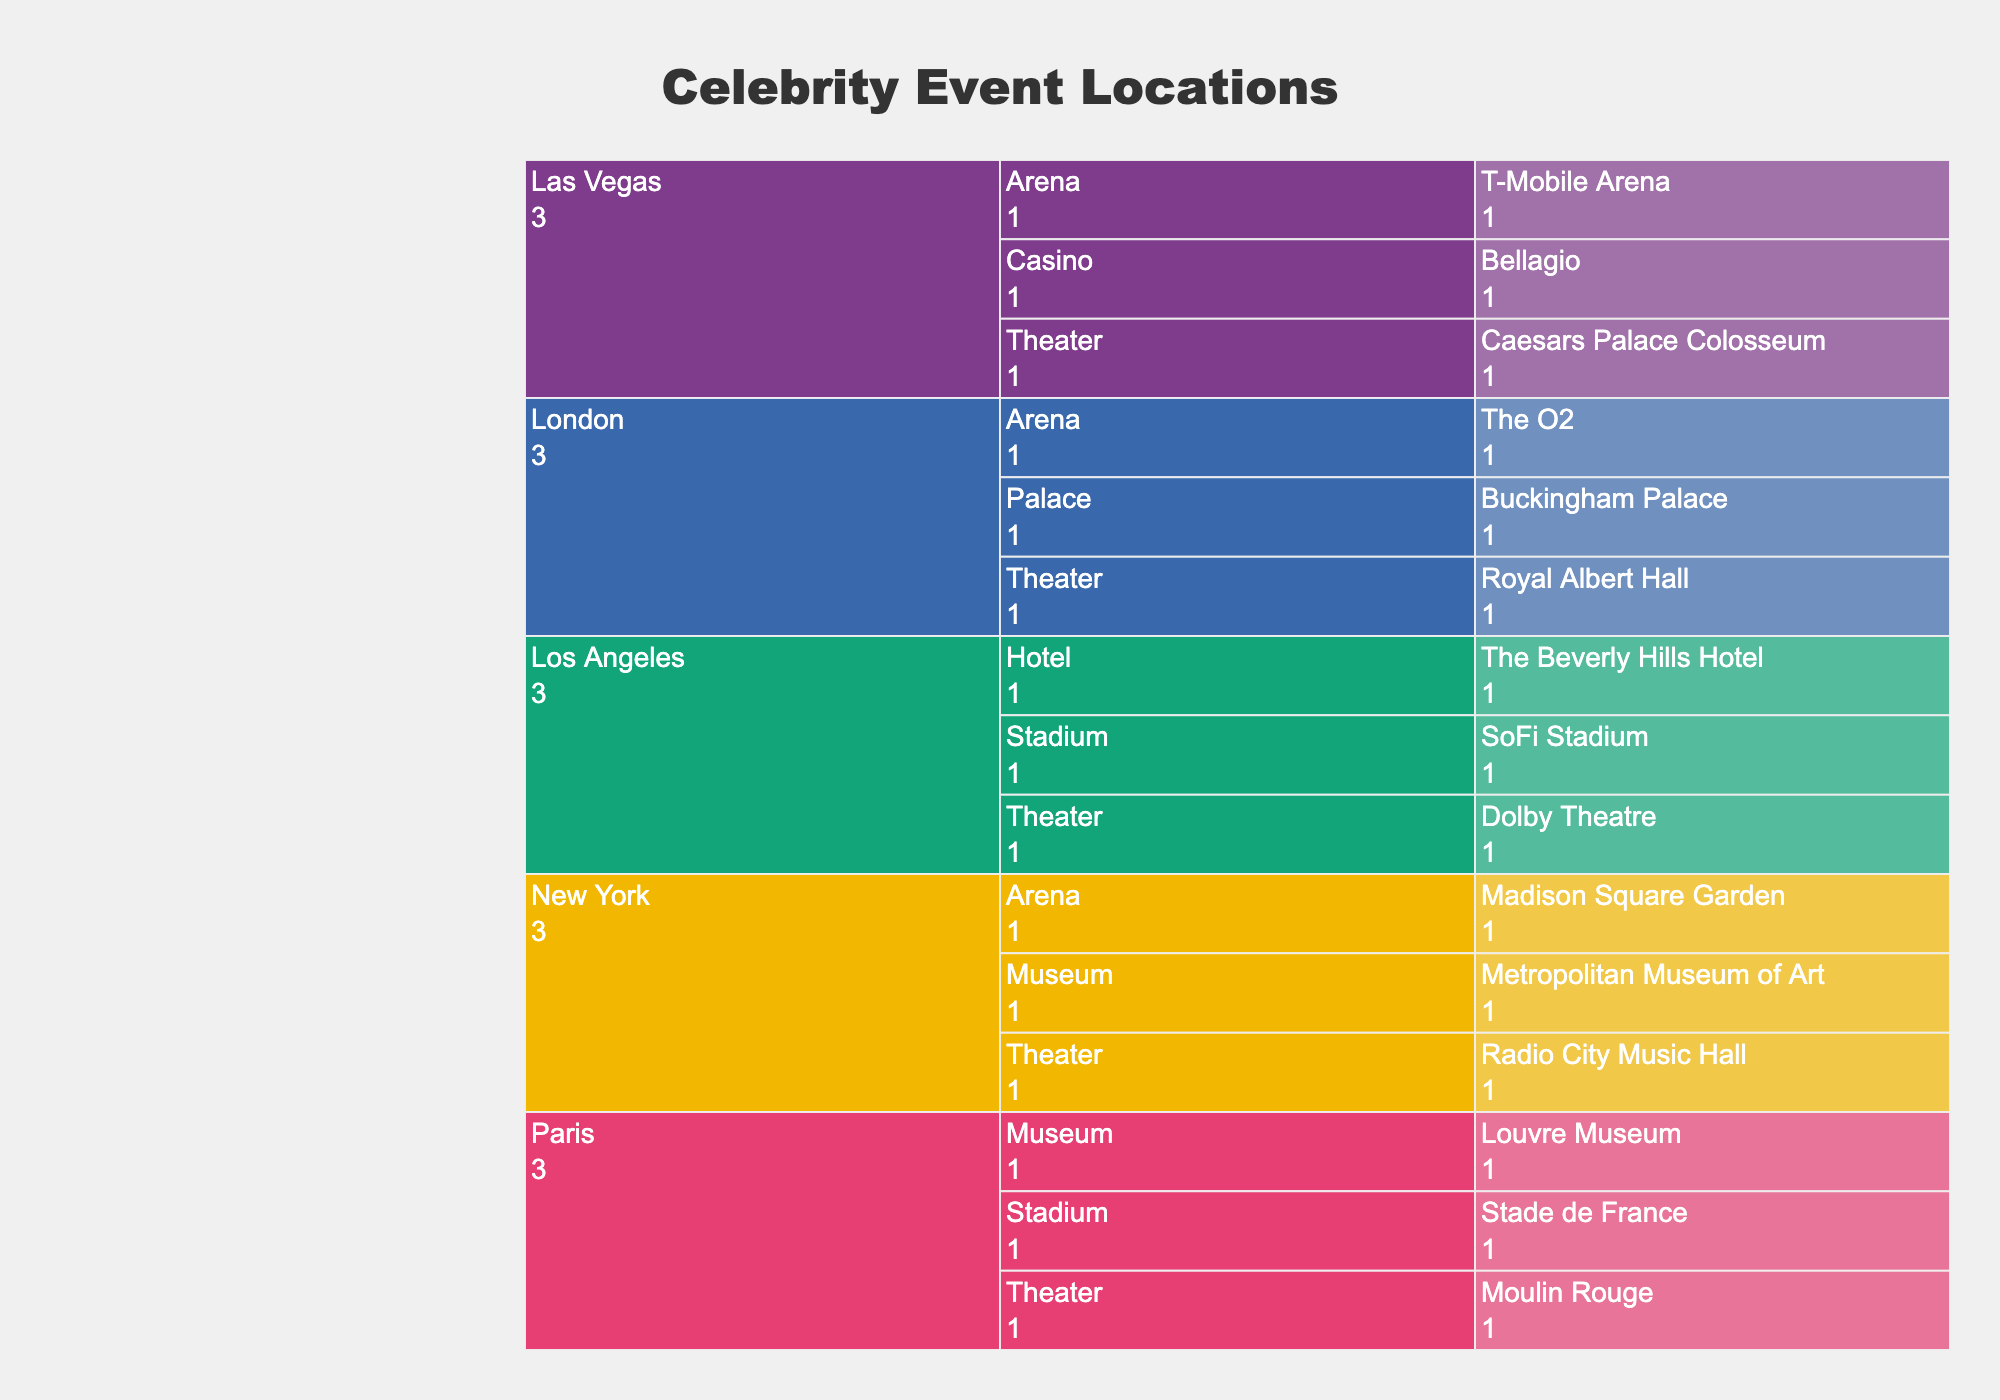what is the main title of the figure? The main title is at the top of the figure and it provides an overview of the content.
Answer: Celebrity Event Locations How many cities are included in the chart? Count the number of distinct cities at the top level of the icicle chart. Each city represents a separate segment in the chart.
Answer: 5 Which city has the most venues listed? Identify the city that expands into the most subsections (venue types and names). This city will have the most nested segments in the chart.
Answer: Los Angeles How many venue types are there in New York? Count the number of unique venue types directly under the New York segment. Each corresponds to a type of venue in the city.
Answer: 3 Which city has a palace as a venue type? Look for the segment labeled 'Palace' and trace it to the city it belongs to. This city will be indicated directly above the palace segment.
Answer: London Compare the number of theaters between Los Angeles and Paris. Which city has more? Identify the theater segments under Los Angeles and Paris. Count the venues listed under each city’s theater segment and compare.
Answer: Los Angeles has more How many venues in total are there in Paris? Count all the individual venue names under the Paris section of the chart. This includes summing venues across different venue types.
Answer: 3 What type of venue is the Beverly Hills Hotel? Find the Beverly Hills Hotel in the chart and identify its direct parent segment to determine its venue type.
Answer: Hotel Which city has the fewest number of venue types? Identify the city with the least number of direct subsections (venue types).
Answer: Paris Are there more arenas or stadiums across all cities? Count all the segments labeled 'Arena' and 'Stadium' across the entire chart and compare their totals.
Answer: Arenas 